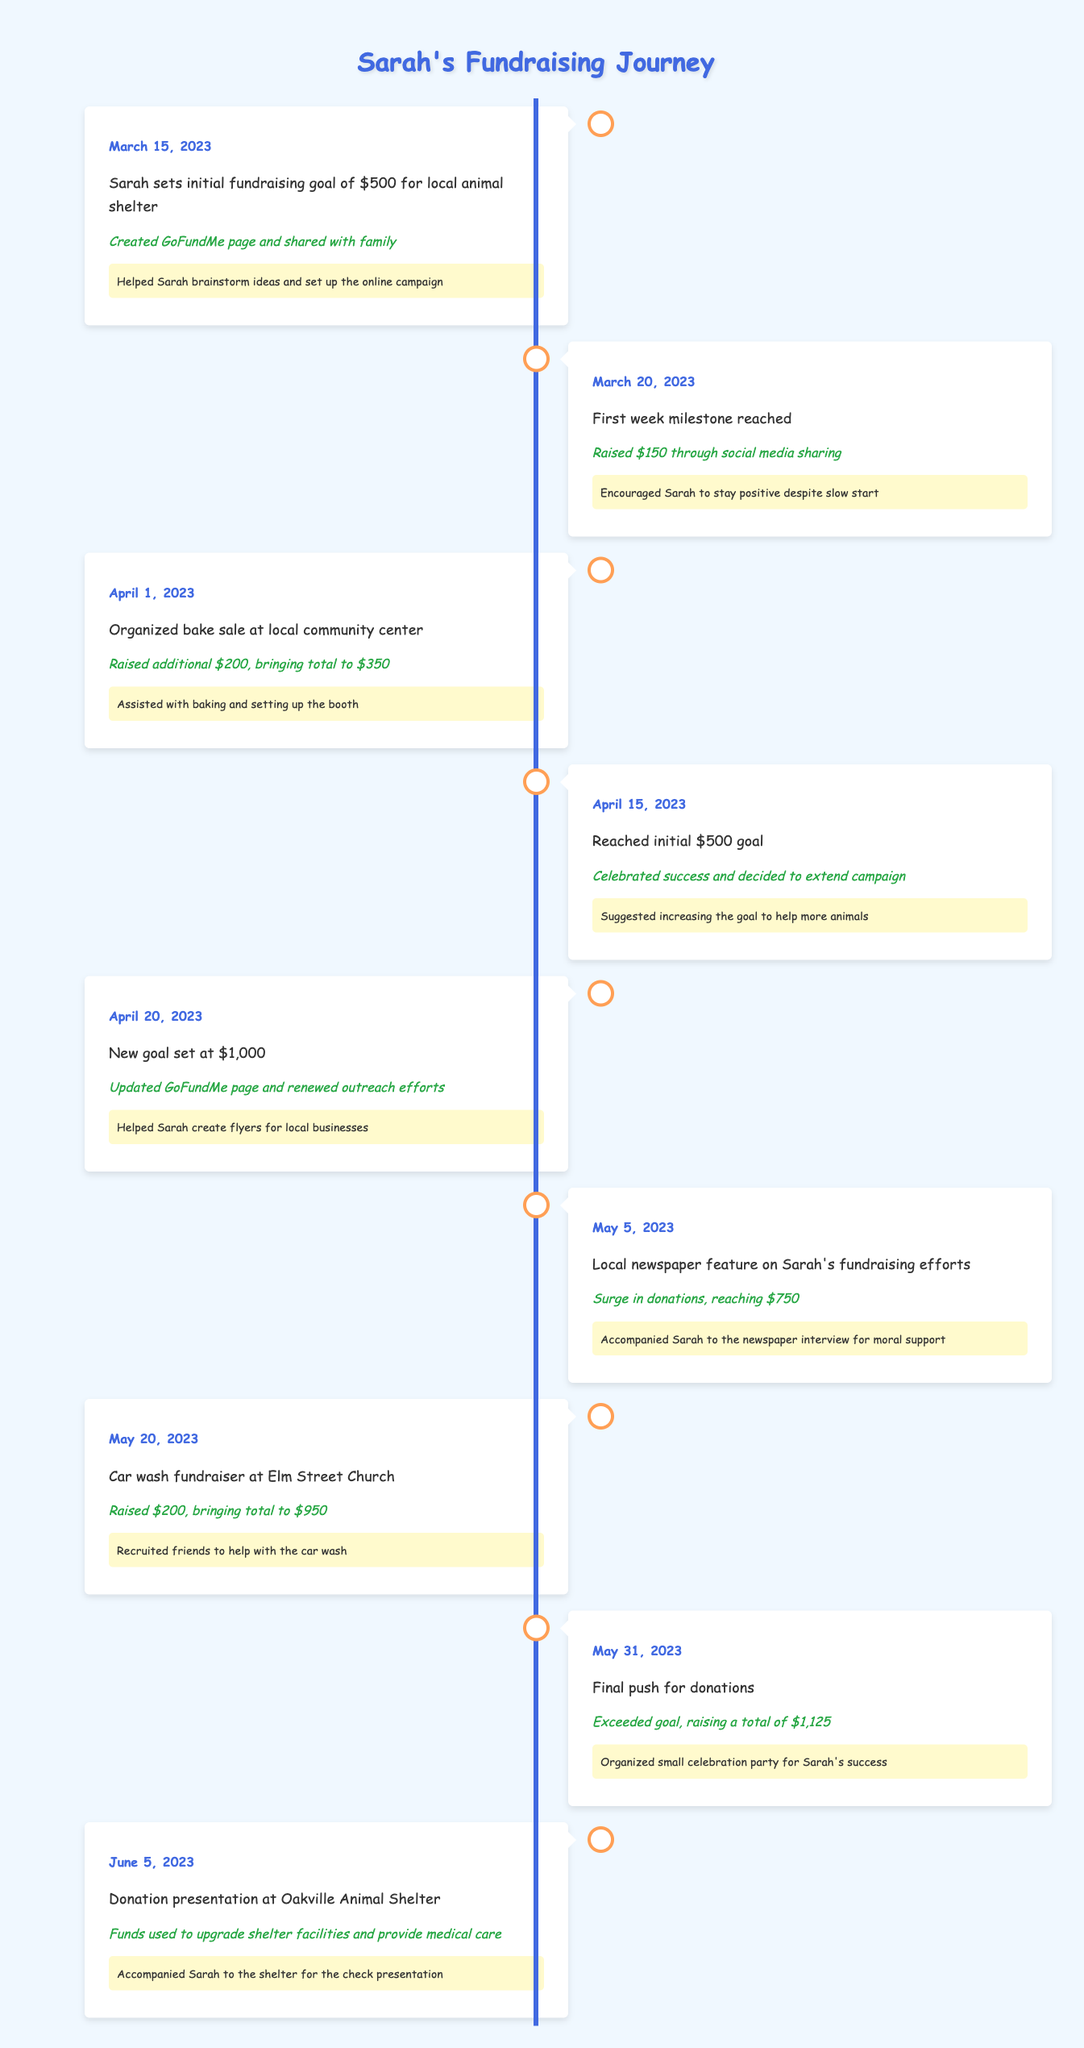What date did Sarah set her initial fundraising goal? The table shows that Sarah set her initial fundraising goal on March 15, 2023. This is the first event listed in the timeline.
Answer: March 15, 2023 How much money did Sarah raise in total by the end of her campaign? The final total amount raised is listed on May 31, 2023, where it says Sarah exceeded her goal by raising a total of $1,125.
Answer: $1,125 Was there a fundraising event that raised $200? The table lists two events where Sarah raised $200: one from the bake sale on April 1, 2023, and another from the car wash at Elm Street Church on May 20, 2023. So the answer is true.
Answer: Yes What was the percentage increase in Sarah's fundraising goal from the initial goal to the new goal? Sarah’s initial goal was $500, and the new goal was set at $1,000. The increase can be calculated as follows: (1000 - 500) / 500 * 100 = 100%. Therefore, the percentage increase is 100%.
Answer: 100% On what date did Sarah achieve her initial fundraising goal? According to the timeline, Sarah reached her initial fundraising goal on April 15, 2023, right before extending the campaign to a new goal.
Answer: April 15, 2023 Which event had the highest financial achievement recorded? The final event on May 31, 2023, reports that Sarah exceeded her fundraising goal and raised a total of $1,125, which is the highest amount recorded in any event listed in the timeline.
Answer: $1,125 How many events did Sarah organize that resulted in raising more than $200? From the table, the bake sale raised $200 and the car wash raised another $200, but both are not more than $200. Only the events before had raised higher funds. Thus, the total number of events that raised more than $200 is zero.
Answer: 0 When was Sarah's fundraising journey featured in the local newspaper? The table shows that she was featured in the local newspaper on May 5, 2023, which resulted in a surge in donations.
Answer: May 5, 2023 Did Sarah receive financial support before reaching her initial goal? Yes, according to the entries, Sarah raised $150 through social media sharing before reaching her initial goal, as shown in the data for March 20, 2023.
Answer: Yes 